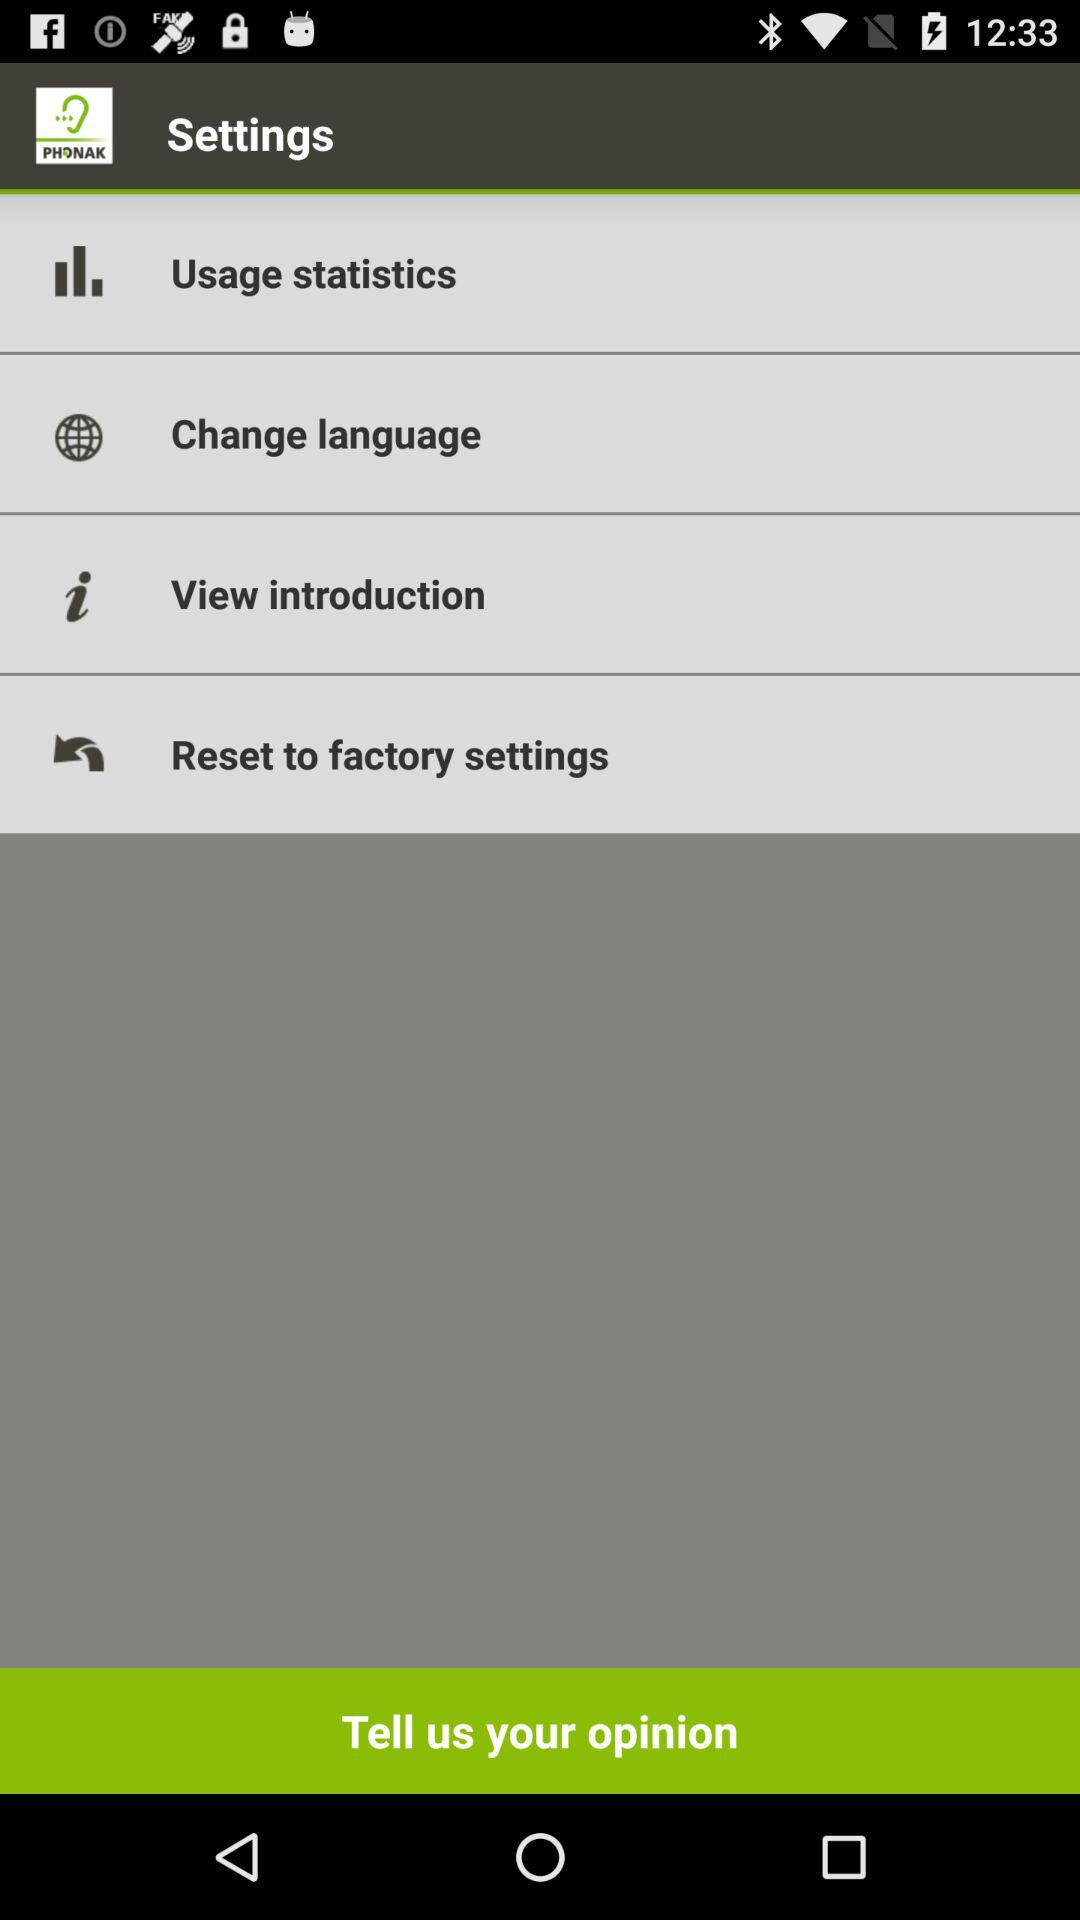How many items are in the settings menu?
Answer the question using a single word or phrase. 4 